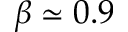<formula> <loc_0><loc_0><loc_500><loc_500>\beta \simeq 0 . 9</formula> 